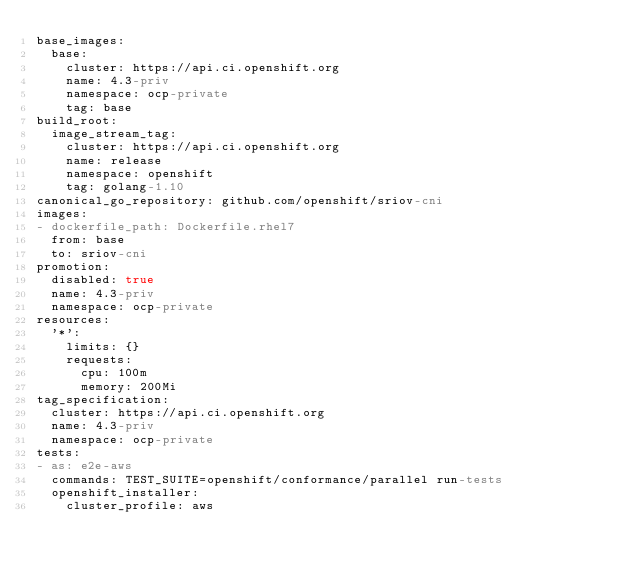Convert code to text. <code><loc_0><loc_0><loc_500><loc_500><_YAML_>base_images:
  base:
    cluster: https://api.ci.openshift.org
    name: 4.3-priv
    namespace: ocp-private
    tag: base
build_root:
  image_stream_tag:
    cluster: https://api.ci.openshift.org
    name: release
    namespace: openshift
    tag: golang-1.10
canonical_go_repository: github.com/openshift/sriov-cni
images:
- dockerfile_path: Dockerfile.rhel7
  from: base
  to: sriov-cni
promotion:
  disabled: true
  name: 4.3-priv
  namespace: ocp-private
resources:
  '*':
    limits: {}
    requests:
      cpu: 100m
      memory: 200Mi
tag_specification:
  cluster: https://api.ci.openshift.org
  name: 4.3-priv
  namespace: ocp-private
tests:
- as: e2e-aws
  commands: TEST_SUITE=openshift/conformance/parallel run-tests
  openshift_installer:
    cluster_profile: aws
</code> 